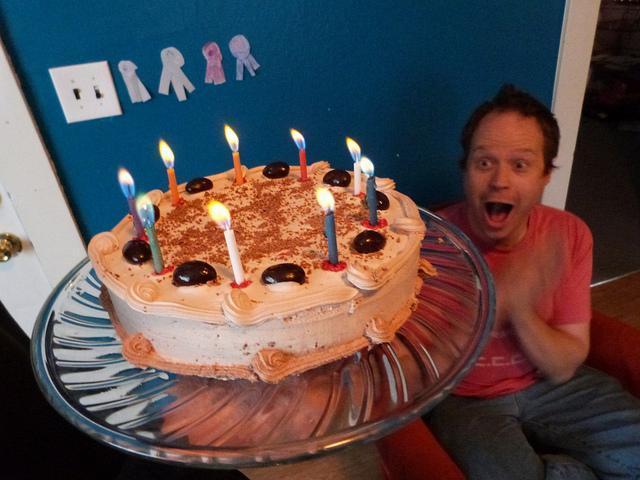How many candles are there?
Give a very brief answer. 9. 